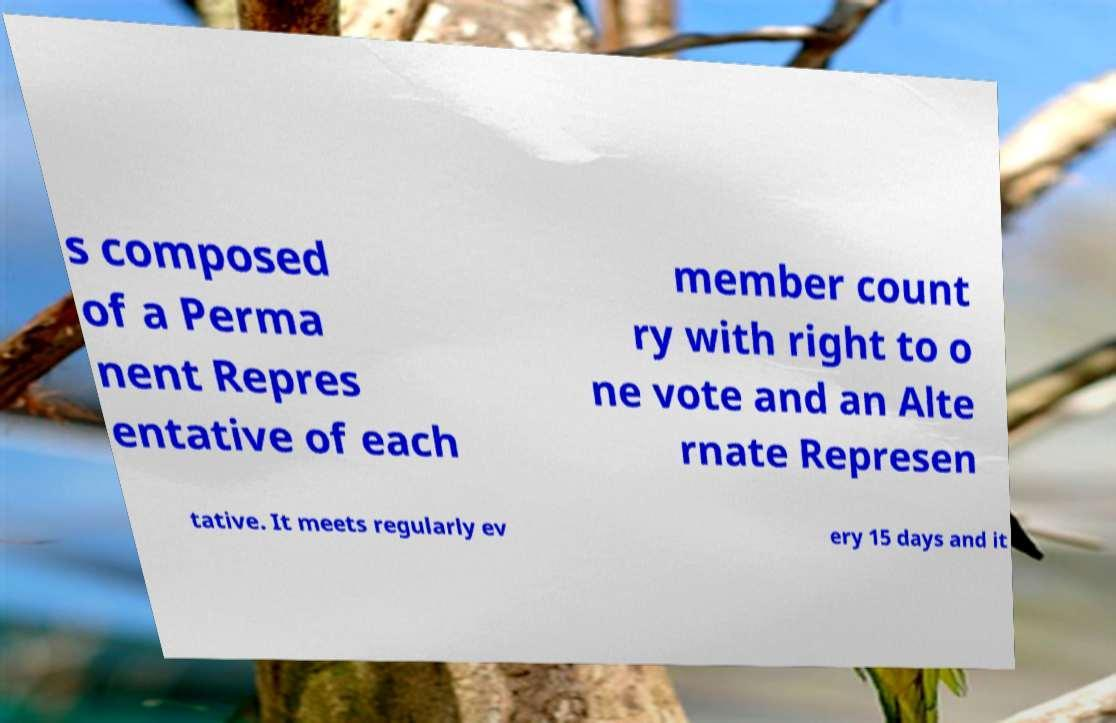What messages or text are displayed in this image? I need them in a readable, typed format. s composed of a Perma nent Repres entative of each member count ry with right to o ne vote and an Alte rnate Represen tative. It meets regularly ev ery 15 days and it 